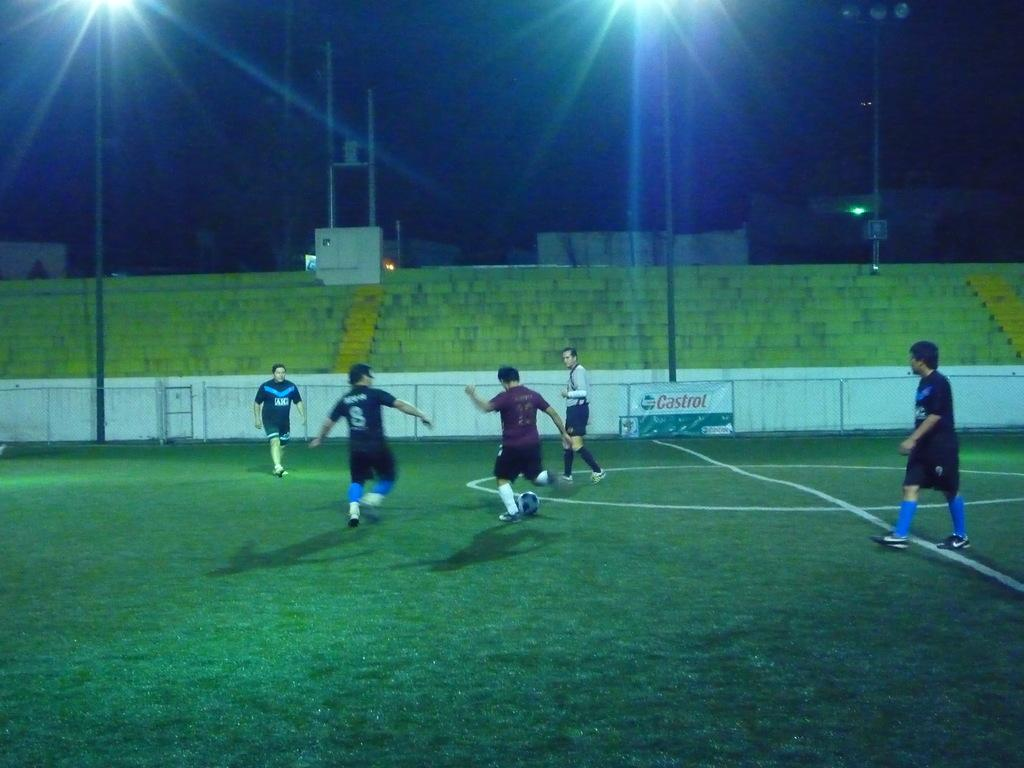<image>
Render a clear and concise summary of the photo. A group of guys on a soccer field in the night with a Castrol oil banner on the wall. 